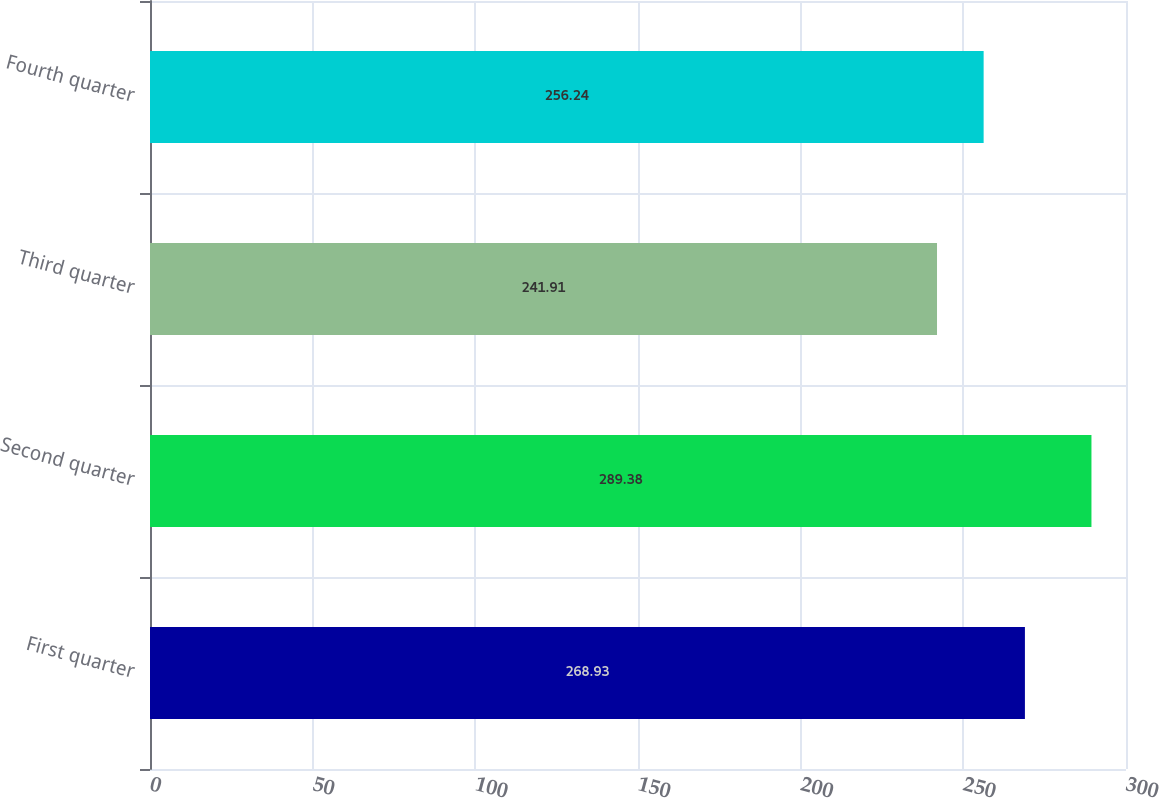Convert chart to OTSL. <chart><loc_0><loc_0><loc_500><loc_500><bar_chart><fcel>First quarter<fcel>Second quarter<fcel>Third quarter<fcel>Fourth quarter<nl><fcel>268.93<fcel>289.38<fcel>241.91<fcel>256.24<nl></chart> 